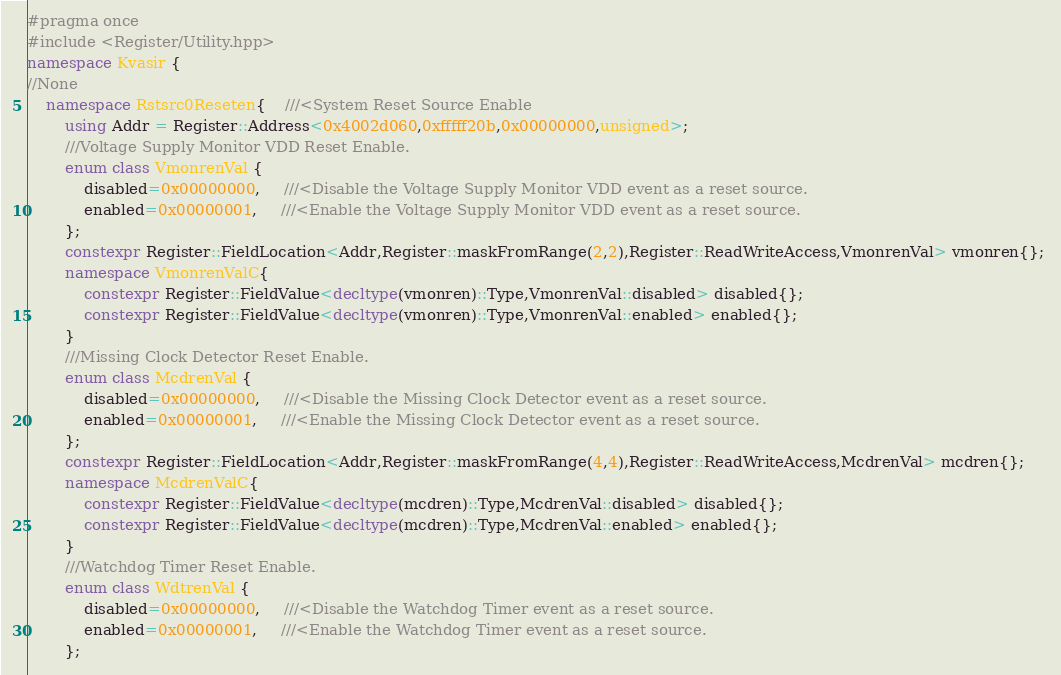<code> <loc_0><loc_0><loc_500><loc_500><_C++_>#pragma once 
#include <Register/Utility.hpp>
namespace Kvasir {
//None
    namespace Rstsrc0Reseten{    ///<System Reset Source Enable
        using Addr = Register::Address<0x4002d060,0xfffff20b,0x00000000,unsigned>;
        ///Voltage Supply Monitor VDD Reset Enable. 
        enum class VmonrenVal {
            disabled=0x00000000,     ///<Disable the Voltage Supply Monitor VDD event as a reset source.
            enabled=0x00000001,     ///<Enable the Voltage Supply Monitor VDD event as a reset source.
        };
        constexpr Register::FieldLocation<Addr,Register::maskFromRange(2,2),Register::ReadWriteAccess,VmonrenVal> vmonren{}; 
        namespace VmonrenValC{
            constexpr Register::FieldValue<decltype(vmonren)::Type,VmonrenVal::disabled> disabled{};
            constexpr Register::FieldValue<decltype(vmonren)::Type,VmonrenVal::enabled> enabled{};
        }
        ///Missing Clock Detector Reset Enable. 
        enum class McdrenVal {
            disabled=0x00000000,     ///<Disable the Missing Clock Detector event as a reset source.
            enabled=0x00000001,     ///<Enable the Missing Clock Detector event as a reset source.
        };
        constexpr Register::FieldLocation<Addr,Register::maskFromRange(4,4),Register::ReadWriteAccess,McdrenVal> mcdren{}; 
        namespace McdrenValC{
            constexpr Register::FieldValue<decltype(mcdren)::Type,McdrenVal::disabled> disabled{};
            constexpr Register::FieldValue<decltype(mcdren)::Type,McdrenVal::enabled> enabled{};
        }
        ///Watchdog Timer Reset Enable. 
        enum class WdtrenVal {
            disabled=0x00000000,     ///<Disable the Watchdog Timer event as a reset source.
            enabled=0x00000001,     ///<Enable the Watchdog Timer event as a reset source.
        };</code> 